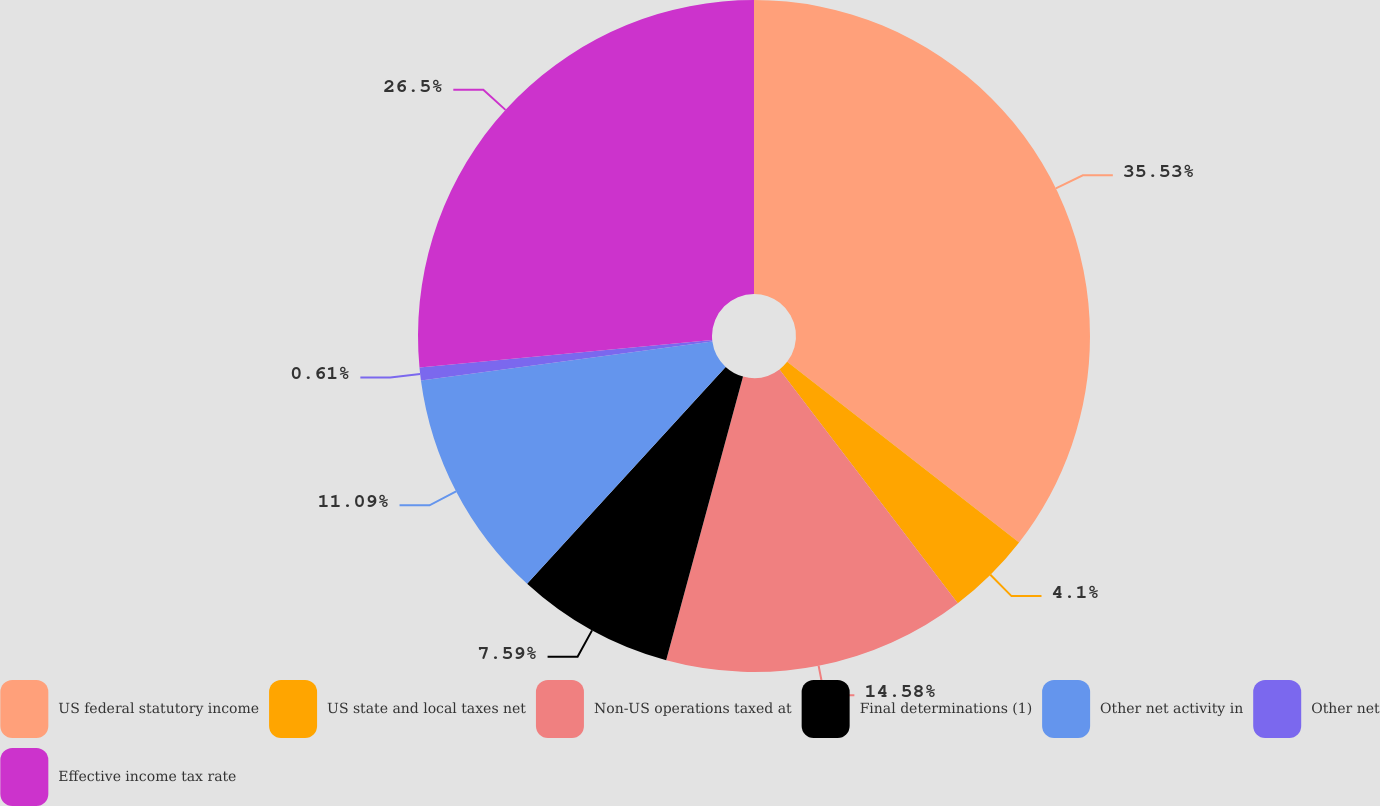Convert chart. <chart><loc_0><loc_0><loc_500><loc_500><pie_chart><fcel>US federal statutory income<fcel>US state and local taxes net<fcel>Non-US operations taxed at<fcel>Final determinations (1)<fcel>Other net activity in<fcel>Other net<fcel>Effective income tax rate<nl><fcel>35.53%<fcel>4.1%<fcel>14.58%<fcel>7.59%<fcel>11.09%<fcel>0.61%<fcel>26.5%<nl></chart> 